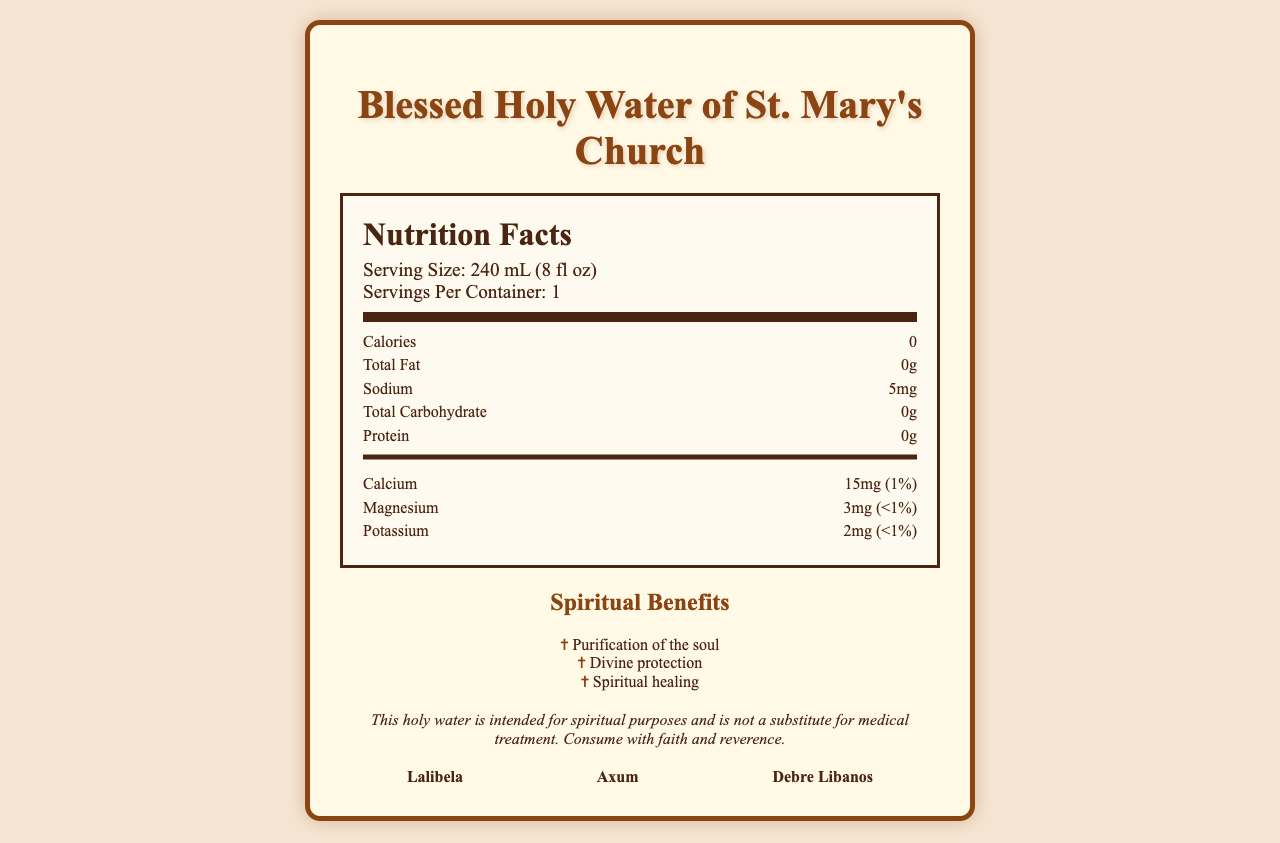what is the serving size of the Blessed Holy Water of St. Mary's Church? The serving size is listed as 240 mL (8 fl oz) at the top of the nutrition label section.
Answer: 240 mL (8 fl oz) how much sodium is present in one serving? Under the nutrition facts, sodium per serving is specified as 5mg.
Answer: 5mg what is the source of this holy water? The purity statement clarifies that the holy water is sourced from the sacred spring of Kidane Mihret Monastery.
Answer: Sacred spring of Kidane Mihret Monastery which mineral has the highest daily value percentage? Calcium has a daily value of 1%, which is higher than Magnesium and Potassium, both less than 1%.
Answer: Calcium how many calories are in a serving of Blessed Holy Water? The document explicitly states that there are 0 calories per serving.
Answer: 0 what are some spiritual benefits of consuming this holy water? The spiritual benefits are listed directly under the spiritual benefits section.
Answer: Purification of the soul, Divine protection, Spiritual healing which of the following minerals is NOT mentioned in the document? A. Iron B. Calcium C. Magnesium D. Potassium The listed minerals are Calcium, Magnesium, and Potassium. Iron is not mentioned.
Answer: A. Iron how is the Blessed Holy Water certified? A. By local health authorities B. By the Ethiopian Orthodox Tewahedo Church C. By an independent lab D. By international standards The document specifies that the water is blessed by His Holiness Abune Mathias I, Patriarch of the Ethiopian Orthodox Tewahedo Church.
Answer: B. By the Ethiopian Orthodox Tewahedo Church is the water free from contaminants? The additional information states that it is free from contaminants.
Answer: Yes summarize the nutritional content of the Blessed Holy Water. This summary covers the key nutritional contents, mineral information, and purity statements from the document.
Answer: The Blessed Holy Water of St. Mary's Church contains 0 calories, 0g of total fat, 5mg of sodium, 0g of total carbohydrates, and 0g of protein. It includes small amounts of minerals such as calcium (15mg), magnesium (3mg), and potassium (2mg). It is sourced from the sacred spring of Kidane Mihret Monastery and is free from contaminants and artificial additives. who blessed the holy water? The blessing certification states that it was blessed by His Holiness Abune Mathias I, Patriarch of the Ethiopian Orthodox Tewahedo Church.
Answer: His Holiness Abune Mathias I what is the precise source of the water? The specific physical location of the Kidane Mihret Monastery’s sacred spring is not provided in the document.
Answer: Cannot be determined which symbols are associated with the holy water? The document lists these symbols under the religious symbols section.
Answer: Ethiopian Cross, Tabot (Ark of the Covenant), Icon of St. Mary 